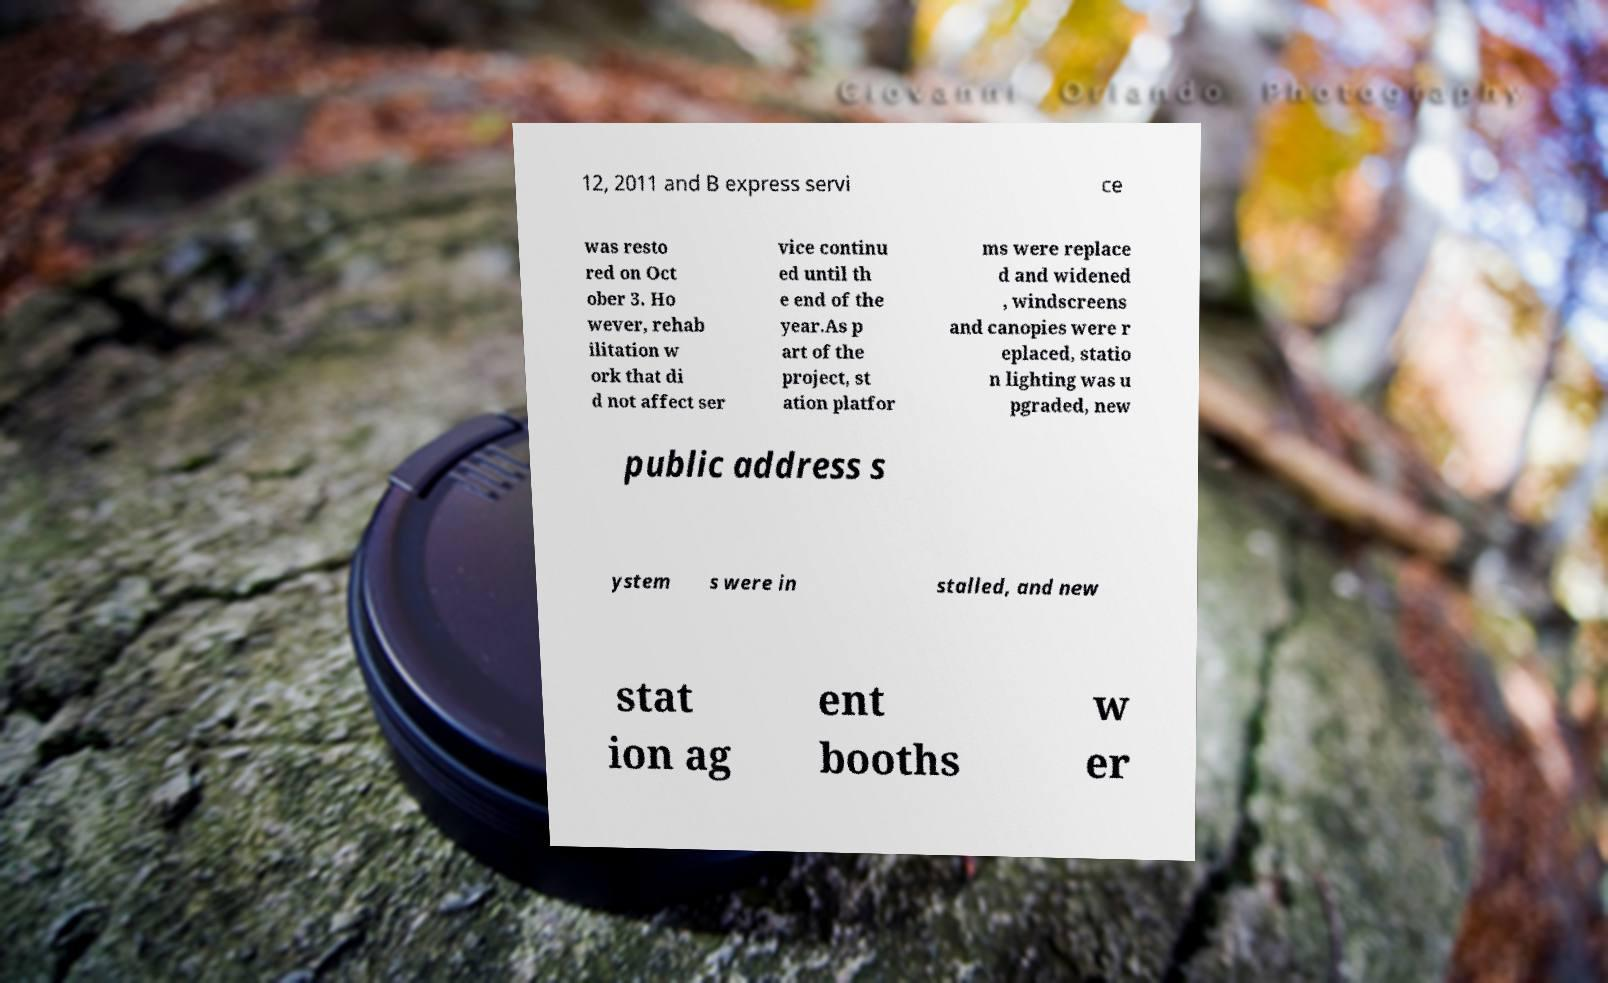Could you assist in decoding the text presented in this image and type it out clearly? 12, 2011 and B express servi ce was resto red on Oct ober 3. Ho wever, rehab ilitation w ork that di d not affect ser vice continu ed until th e end of the year.As p art of the project, st ation platfor ms were replace d and widened , windscreens and canopies were r eplaced, statio n lighting was u pgraded, new public address s ystem s were in stalled, and new stat ion ag ent booths w er 